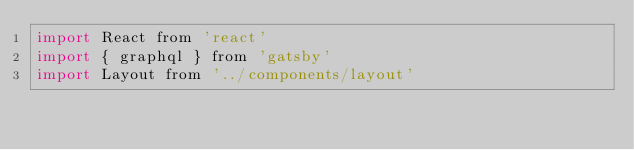<code> <loc_0><loc_0><loc_500><loc_500><_JavaScript_>import React from 'react'
import { graphql } from 'gatsby'
import Layout from '../components/layout'

</code> 